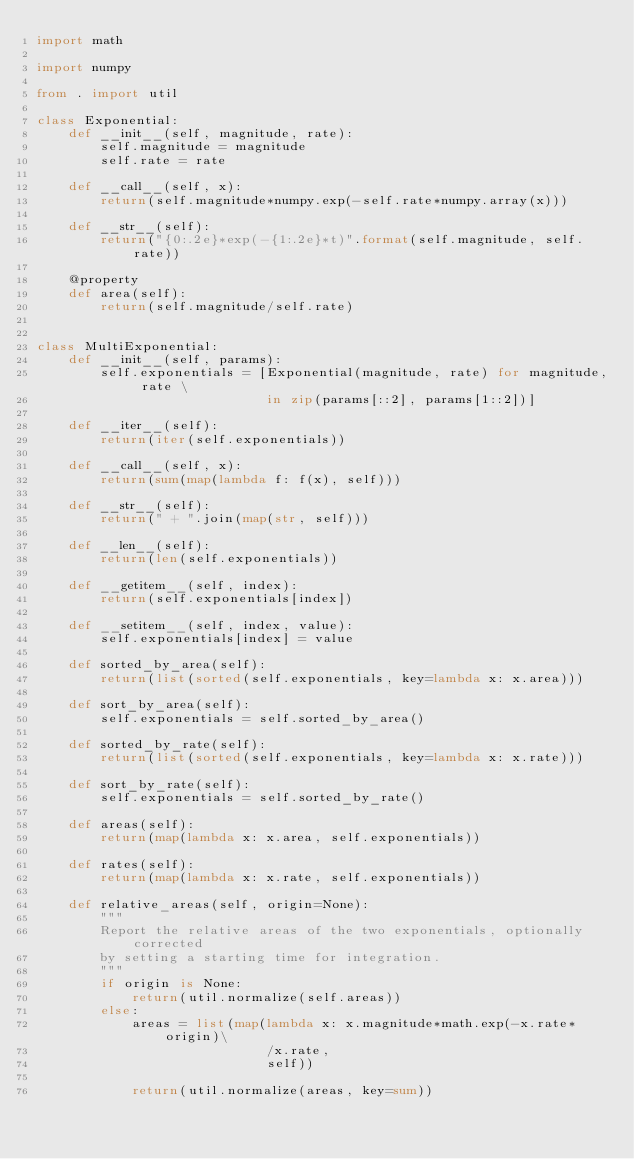Convert code to text. <code><loc_0><loc_0><loc_500><loc_500><_Python_>import math

import numpy

from . import util

class Exponential:
    def __init__(self, magnitude, rate):
        self.magnitude = magnitude
        self.rate = rate

    def __call__(self, x):
        return(self.magnitude*numpy.exp(-self.rate*numpy.array(x)))

    def __str__(self):
        return("{0:.2e}*exp(-{1:.2e}*t)".format(self.magnitude, self.rate))

    @property
    def area(self):
        return(self.magnitude/self.rate)


class MultiExponential:
    def __init__(self, params):
        self.exponentials = [Exponential(magnitude, rate) for magnitude, rate \
                             in zip(params[::2], params[1::2])]

    def __iter__(self):
        return(iter(self.exponentials))
    
    def __call__(self, x):
        return(sum(map(lambda f: f(x), self)))

    def __str__(self):
        return(" + ".join(map(str, self)))

    def __len__(self):
        return(len(self.exponentials))

    def __getitem__(self, index):
        return(self.exponentials[index])

    def __setitem__(self, index, value):
        self.exponentials[index] = value

    def sorted_by_area(self):
        return(list(sorted(self.exponentials, key=lambda x: x.area)))

    def sort_by_area(self):
        self.exponentials = self.sorted_by_area()

    def sorted_by_rate(self):
        return(list(sorted(self.exponentials, key=lambda x: x.rate)))

    def sort_by_rate(self):
        self.exponentials = self.sorted_by_rate()

    def areas(self):
        return(map(lambda x: x.area, self.exponentials))

    def rates(self):
        return(map(lambda x: x.rate, self.exponentials))

    def relative_areas(self, origin=None):
        """
        Report the relative areas of the two exponentials, optionally corrected
        by setting a starting time for integration.
        """
        if origin is None:
            return(util.normalize(self.areas))
        else:
            areas = list(map(lambda x: x.magnitude*math.exp(-x.rate*origin)\
                             /x.rate,
                             self))

            return(util.normalize(areas, key=sum))
            

</code> 